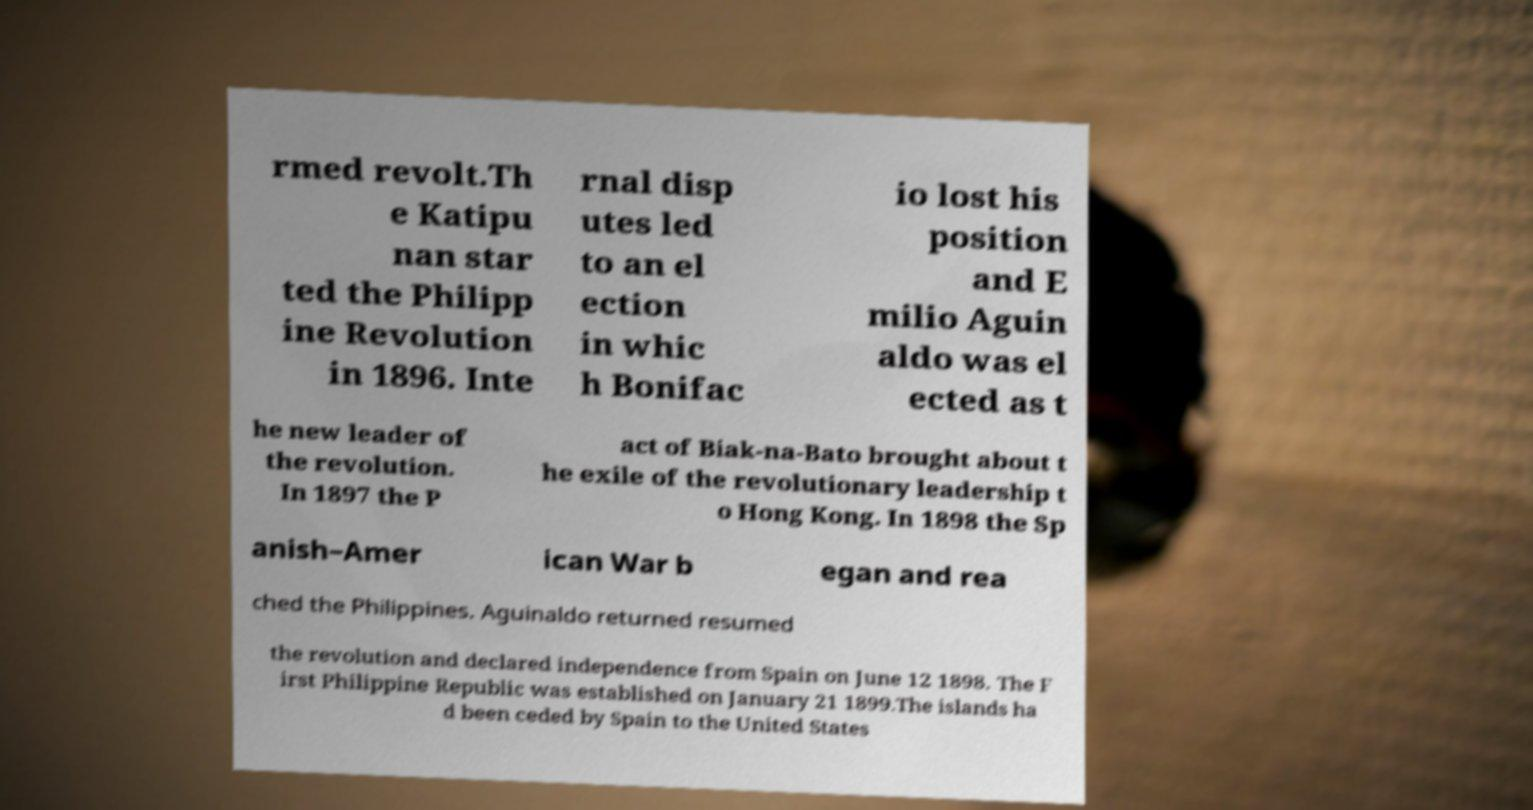Can you read and provide the text displayed in the image?This photo seems to have some interesting text. Can you extract and type it out for me? rmed revolt.Th e Katipu nan star ted the Philipp ine Revolution in 1896. Inte rnal disp utes led to an el ection in whic h Bonifac io lost his position and E milio Aguin aldo was el ected as t he new leader of the revolution. In 1897 the P act of Biak-na-Bato brought about t he exile of the revolutionary leadership t o Hong Kong. In 1898 the Sp anish–Amer ican War b egan and rea ched the Philippines. Aguinaldo returned resumed the revolution and declared independence from Spain on June 12 1898. The F irst Philippine Republic was established on January 21 1899.The islands ha d been ceded by Spain to the United States 